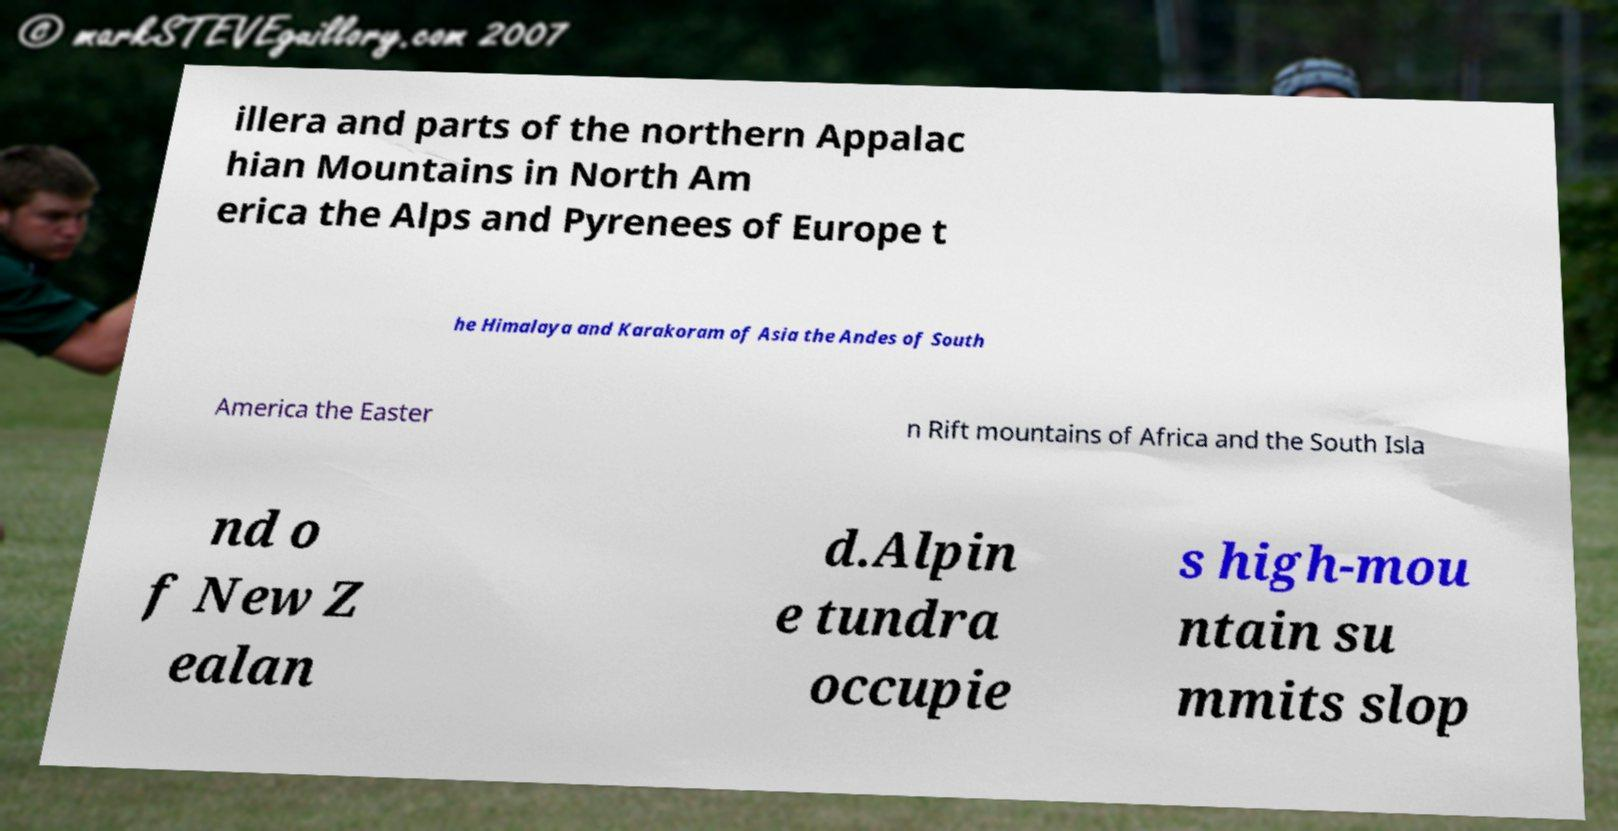Please identify and transcribe the text found in this image. illera and parts of the northern Appalac hian Mountains in North Am erica the Alps and Pyrenees of Europe t he Himalaya and Karakoram of Asia the Andes of South America the Easter n Rift mountains of Africa and the South Isla nd o f New Z ealan d.Alpin e tundra occupie s high-mou ntain su mmits slop 